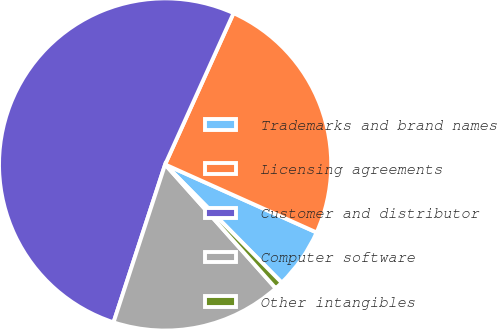Convert chart. <chart><loc_0><loc_0><loc_500><loc_500><pie_chart><fcel>Trademarks and brand names<fcel>Licensing agreements<fcel>Customer and distributor<fcel>Computer software<fcel>Other intangibles<nl><fcel>5.89%<fcel>24.96%<fcel>51.73%<fcel>16.63%<fcel>0.79%<nl></chart> 